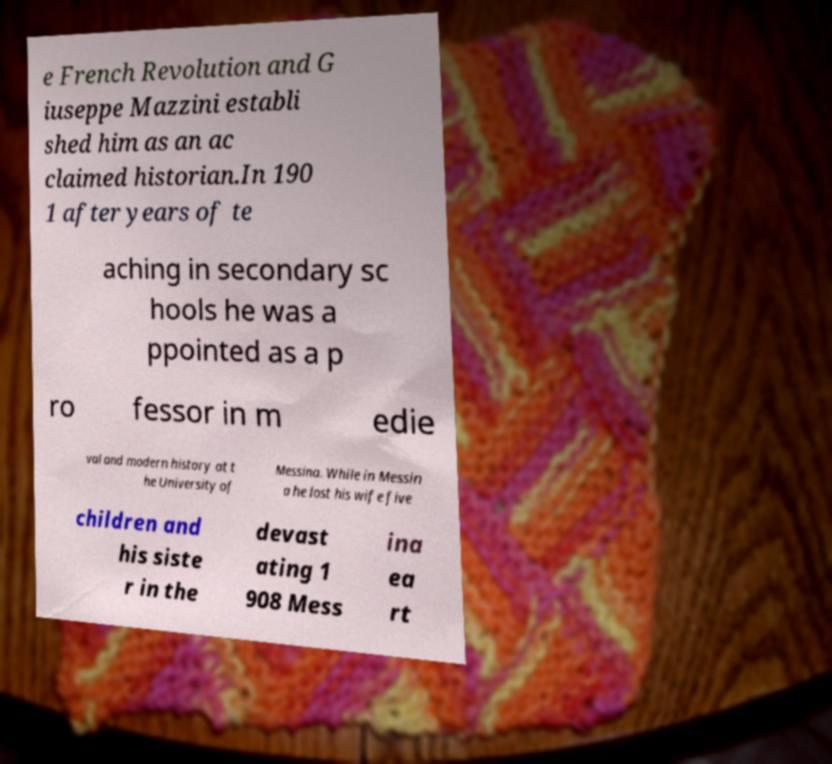Could you extract and type out the text from this image? e French Revolution and G iuseppe Mazzini establi shed him as an ac claimed historian.In 190 1 after years of te aching in secondary sc hools he was a ppointed as a p ro fessor in m edie val and modern history at t he University of Messina. While in Messin a he lost his wife five children and his siste r in the devast ating 1 908 Mess ina ea rt 